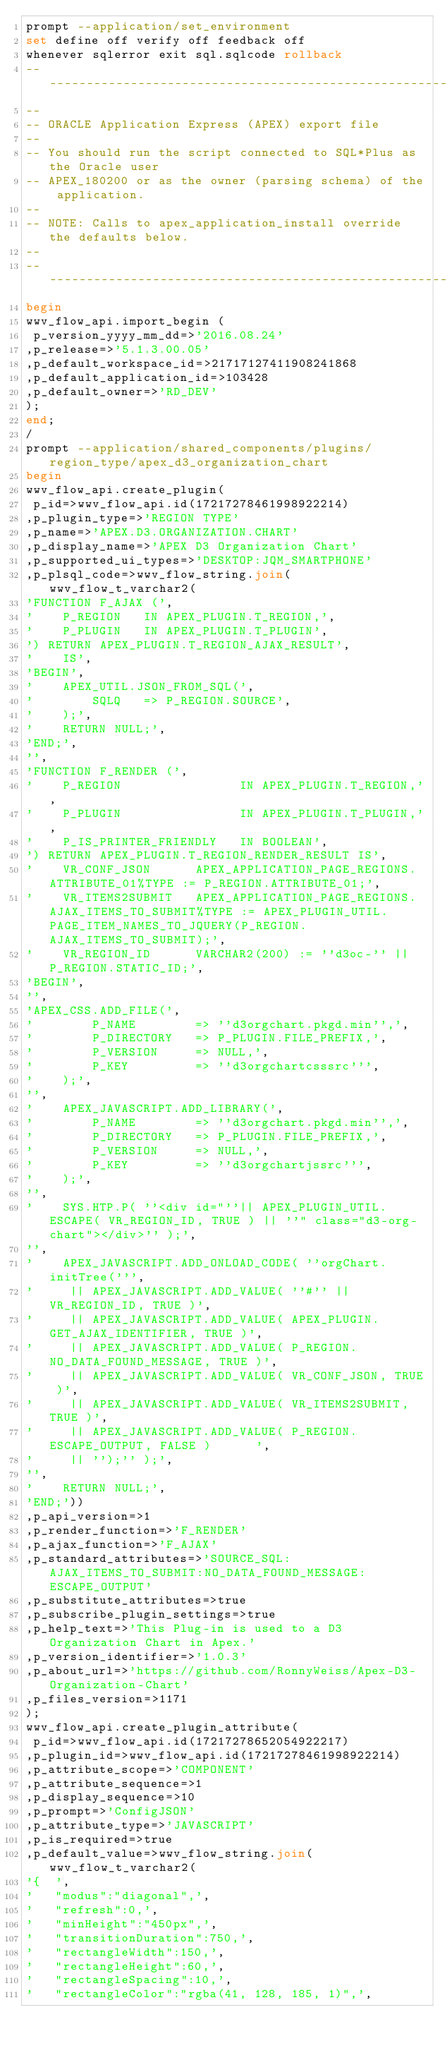Convert code to text. <code><loc_0><loc_0><loc_500><loc_500><_SQL_>prompt --application/set_environment
set define off verify off feedback off
whenever sqlerror exit sql.sqlcode rollback
--------------------------------------------------------------------------------
--
-- ORACLE Application Express (APEX) export file
--
-- You should run the script connected to SQL*Plus as the Oracle user
-- APEX_180200 or as the owner (parsing schema) of the application.
--
-- NOTE: Calls to apex_application_install override the defaults below.
--
--------------------------------------------------------------------------------
begin
wwv_flow_api.import_begin (
 p_version_yyyy_mm_dd=>'2016.08.24'
,p_release=>'5.1.3.00.05'
,p_default_workspace_id=>21717127411908241868
,p_default_application_id=>103428
,p_default_owner=>'RD_DEV'
);
end;
/
prompt --application/shared_components/plugins/region_type/apex_d3_organization_chart
begin
wwv_flow_api.create_plugin(
 p_id=>wwv_flow_api.id(17217278461998922214)
,p_plugin_type=>'REGION TYPE'
,p_name=>'APEX.D3.ORGANIZATION.CHART'
,p_display_name=>'APEX D3 Organization Chart'
,p_supported_ui_types=>'DESKTOP:JQM_SMARTPHONE'
,p_plsql_code=>wwv_flow_string.join(wwv_flow_t_varchar2(
'FUNCTION F_AJAX (',
'    P_REGION   IN APEX_PLUGIN.T_REGION,',
'    P_PLUGIN   IN APEX_PLUGIN.T_PLUGIN',
') RETURN APEX_PLUGIN.T_REGION_AJAX_RESULT',
'    IS',
'BEGIN',
'    APEX_UTIL.JSON_FROM_SQL(',
'        SQLQ   => P_REGION.SOURCE',
'    );',
'    RETURN NULL;',
'END;',
'',
'FUNCTION F_RENDER (',
'    P_REGION                IN APEX_PLUGIN.T_REGION,',
'    P_PLUGIN                IN APEX_PLUGIN.T_PLUGIN,',
'    P_IS_PRINTER_FRIENDLY   IN BOOLEAN',
') RETURN APEX_PLUGIN.T_REGION_RENDER_RESULT IS',
'    VR_CONF_JSON      APEX_APPLICATION_PAGE_REGIONS.ATTRIBUTE_01%TYPE := P_REGION.ATTRIBUTE_01;',
'    VR_ITEMS2SUBMIT   APEX_APPLICATION_PAGE_REGIONS.AJAX_ITEMS_TO_SUBMIT%TYPE := APEX_PLUGIN_UTIL.PAGE_ITEM_NAMES_TO_JQUERY(P_REGION.AJAX_ITEMS_TO_SUBMIT);',
'    VR_REGION_ID      VARCHAR2(200) := ''d3oc-'' || P_REGION.STATIC_ID;',
'BEGIN',
'',
'APEX_CSS.ADD_FILE(',
'        P_NAME        => ''d3orgchart.pkgd.min'',',
'        P_DIRECTORY   => P_PLUGIN.FILE_PREFIX,',
'        P_VERSION     => NULL,',
'        P_KEY         => ''d3orgchartcsssrc''',
'    );',
'',
'    APEX_JAVASCRIPT.ADD_LIBRARY(',
'        P_NAME        => ''d3orgchart.pkgd.min'',',
'        P_DIRECTORY   => P_PLUGIN.FILE_PREFIX,',
'        P_VERSION     => NULL,',
'        P_KEY         => ''d3orgchartjssrc''',
'    );',
'',
'    SYS.HTP.P( ''<div id="''|| APEX_PLUGIN_UTIL.ESCAPE( VR_REGION_ID, TRUE ) || ''" class="d3-org-chart"></div>'' );',
'',
'    APEX_JAVASCRIPT.ADD_ONLOAD_CODE( ''orgChart.initTree(''',
'     || APEX_JAVASCRIPT.ADD_VALUE( ''#'' || VR_REGION_ID, TRUE )',
'     || APEX_JAVASCRIPT.ADD_VALUE( APEX_PLUGIN.GET_AJAX_IDENTIFIER, TRUE )',
'     || APEX_JAVASCRIPT.ADD_VALUE( P_REGION.NO_DATA_FOUND_MESSAGE, TRUE )',
'     || APEX_JAVASCRIPT.ADD_VALUE( VR_CONF_JSON, TRUE )',
'     || APEX_JAVASCRIPT.ADD_VALUE( VR_ITEMS2SUBMIT, TRUE )',
'     || APEX_JAVASCRIPT.ADD_VALUE( P_REGION.ESCAPE_OUTPUT, FALSE )      ',
'     || '');'' );',
'',
'    RETURN NULL;',
'END;'))
,p_api_version=>1
,p_render_function=>'F_RENDER'
,p_ajax_function=>'F_AJAX'
,p_standard_attributes=>'SOURCE_SQL:AJAX_ITEMS_TO_SUBMIT:NO_DATA_FOUND_MESSAGE:ESCAPE_OUTPUT'
,p_substitute_attributes=>true
,p_subscribe_plugin_settings=>true
,p_help_text=>'This Plug-in is used to a D3 Organization Chart in Apex.'
,p_version_identifier=>'1.0.3'
,p_about_url=>'https://github.com/RonnyWeiss/Apex-D3-Organization-Chart'
,p_files_version=>1171
);
wwv_flow_api.create_plugin_attribute(
 p_id=>wwv_flow_api.id(17217278652054922217)
,p_plugin_id=>wwv_flow_api.id(17217278461998922214)
,p_attribute_scope=>'COMPONENT'
,p_attribute_sequence=>1
,p_display_sequence=>10
,p_prompt=>'ConfigJSON'
,p_attribute_type=>'JAVASCRIPT'
,p_is_required=>true
,p_default_value=>wwv_flow_string.join(wwv_flow_t_varchar2(
'{  ',
'   "modus":"diagonal",',
'   "refresh":0,',
'   "minHeight":"450px",',
'   "transitionDuration":750,',
'   "rectangleWidth":150,',
'   "rectangleHeight":60,',
'   "rectangleSpacing":10,',
'   "rectangleColor":"rgba(41, 128, 185, 1)",',</code> 